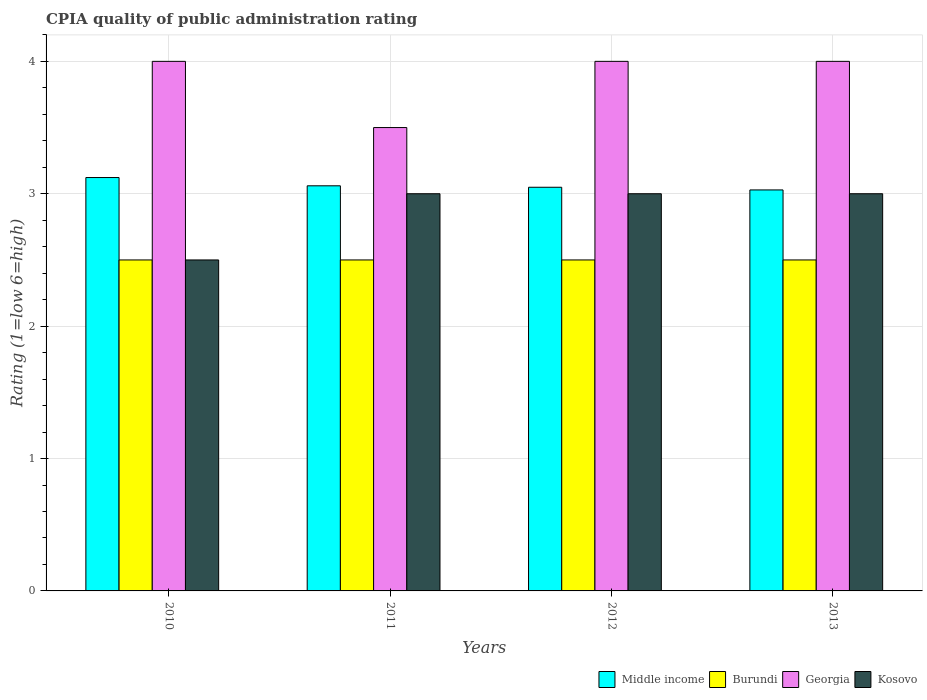What is the label of the 3rd group of bars from the left?
Your answer should be compact. 2012. What is the CPIA rating in Middle income in 2012?
Your answer should be very brief. 3.05. Across all years, what is the minimum CPIA rating in Middle income?
Make the answer very short. 3.03. In which year was the CPIA rating in Kosovo maximum?
Make the answer very short. 2011. What is the difference between the CPIA rating in Middle income in 2012 and the CPIA rating in Georgia in 2013?
Your answer should be compact. -0.95. What is the average CPIA rating in Georgia per year?
Ensure brevity in your answer.  3.88. In the year 2012, what is the difference between the CPIA rating in Middle income and CPIA rating in Kosovo?
Your response must be concise. 0.05. In how many years, is the CPIA rating in Middle income greater than 2?
Give a very brief answer. 4. What is the difference between the highest and the second highest CPIA rating in Kosovo?
Your answer should be compact. 0. Is it the case that in every year, the sum of the CPIA rating in Burundi and CPIA rating in Kosovo is greater than the sum of CPIA rating in Middle income and CPIA rating in Georgia?
Give a very brief answer. No. What does the 3rd bar from the left in 2010 represents?
Your answer should be compact. Georgia. Is it the case that in every year, the sum of the CPIA rating in Burundi and CPIA rating in Georgia is greater than the CPIA rating in Middle income?
Your answer should be compact. Yes. Are all the bars in the graph horizontal?
Offer a terse response. No. What is the difference between two consecutive major ticks on the Y-axis?
Make the answer very short. 1. Are the values on the major ticks of Y-axis written in scientific E-notation?
Provide a short and direct response. No. Does the graph contain grids?
Ensure brevity in your answer.  Yes. Where does the legend appear in the graph?
Give a very brief answer. Bottom right. What is the title of the graph?
Give a very brief answer. CPIA quality of public administration rating. What is the label or title of the X-axis?
Your response must be concise. Years. What is the Rating (1=low 6=high) of Middle income in 2010?
Offer a very short reply. 3.12. What is the Rating (1=low 6=high) in Kosovo in 2010?
Your answer should be compact. 2.5. What is the Rating (1=low 6=high) in Middle income in 2011?
Your response must be concise. 3.06. What is the Rating (1=low 6=high) in Burundi in 2011?
Your answer should be compact. 2.5. What is the Rating (1=low 6=high) in Georgia in 2011?
Keep it short and to the point. 3.5. What is the Rating (1=low 6=high) in Middle income in 2012?
Offer a terse response. 3.05. What is the Rating (1=low 6=high) of Kosovo in 2012?
Make the answer very short. 3. What is the Rating (1=low 6=high) of Middle income in 2013?
Make the answer very short. 3.03. What is the Rating (1=low 6=high) of Burundi in 2013?
Your response must be concise. 2.5. What is the Rating (1=low 6=high) of Georgia in 2013?
Provide a short and direct response. 4. What is the Rating (1=low 6=high) in Kosovo in 2013?
Provide a succinct answer. 3. Across all years, what is the maximum Rating (1=low 6=high) of Middle income?
Your answer should be compact. 3.12. Across all years, what is the maximum Rating (1=low 6=high) in Burundi?
Your response must be concise. 2.5. Across all years, what is the maximum Rating (1=low 6=high) of Georgia?
Offer a very short reply. 4. Across all years, what is the maximum Rating (1=low 6=high) of Kosovo?
Your response must be concise. 3. Across all years, what is the minimum Rating (1=low 6=high) in Middle income?
Offer a terse response. 3.03. Across all years, what is the minimum Rating (1=low 6=high) in Georgia?
Your answer should be very brief. 3.5. What is the total Rating (1=low 6=high) of Middle income in the graph?
Your answer should be very brief. 12.26. What is the total Rating (1=low 6=high) of Burundi in the graph?
Your answer should be compact. 10. What is the total Rating (1=low 6=high) in Kosovo in the graph?
Offer a terse response. 11.5. What is the difference between the Rating (1=low 6=high) in Middle income in 2010 and that in 2011?
Ensure brevity in your answer.  0.06. What is the difference between the Rating (1=low 6=high) of Georgia in 2010 and that in 2011?
Provide a short and direct response. 0.5. What is the difference between the Rating (1=low 6=high) in Middle income in 2010 and that in 2012?
Make the answer very short. 0.07. What is the difference between the Rating (1=low 6=high) in Burundi in 2010 and that in 2012?
Your answer should be compact. 0. What is the difference between the Rating (1=low 6=high) in Georgia in 2010 and that in 2012?
Keep it short and to the point. 0. What is the difference between the Rating (1=low 6=high) in Middle income in 2010 and that in 2013?
Provide a short and direct response. 0.09. What is the difference between the Rating (1=low 6=high) in Georgia in 2010 and that in 2013?
Keep it short and to the point. 0. What is the difference between the Rating (1=low 6=high) of Kosovo in 2010 and that in 2013?
Make the answer very short. -0.5. What is the difference between the Rating (1=low 6=high) in Middle income in 2011 and that in 2012?
Provide a short and direct response. 0.01. What is the difference between the Rating (1=low 6=high) of Georgia in 2011 and that in 2012?
Ensure brevity in your answer.  -0.5. What is the difference between the Rating (1=low 6=high) in Kosovo in 2011 and that in 2012?
Offer a terse response. 0. What is the difference between the Rating (1=low 6=high) in Middle income in 2011 and that in 2013?
Ensure brevity in your answer.  0.03. What is the difference between the Rating (1=low 6=high) in Georgia in 2011 and that in 2013?
Make the answer very short. -0.5. What is the difference between the Rating (1=low 6=high) of Middle income in 2012 and that in 2013?
Your answer should be very brief. 0.02. What is the difference between the Rating (1=low 6=high) in Georgia in 2012 and that in 2013?
Ensure brevity in your answer.  0. What is the difference between the Rating (1=low 6=high) in Kosovo in 2012 and that in 2013?
Offer a terse response. 0. What is the difference between the Rating (1=low 6=high) in Middle income in 2010 and the Rating (1=low 6=high) in Burundi in 2011?
Give a very brief answer. 0.62. What is the difference between the Rating (1=low 6=high) of Middle income in 2010 and the Rating (1=low 6=high) of Georgia in 2011?
Make the answer very short. -0.38. What is the difference between the Rating (1=low 6=high) in Middle income in 2010 and the Rating (1=low 6=high) in Kosovo in 2011?
Keep it short and to the point. 0.12. What is the difference between the Rating (1=low 6=high) of Middle income in 2010 and the Rating (1=low 6=high) of Burundi in 2012?
Ensure brevity in your answer.  0.62. What is the difference between the Rating (1=low 6=high) in Middle income in 2010 and the Rating (1=low 6=high) in Georgia in 2012?
Provide a short and direct response. -0.88. What is the difference between the Rating (1=low 6=high) in Middle income in 2010 and the Rating (1=low 6=high) in Kosovo in 2012?
Offer a terse response. 0.12. What is the difference between the Rating (1=low 6=high) of Burundi in 2010 and the Rating (1=low 6=high) of Georgia in 2012?
Keep it short and to the point. -1.5. What is the difference between the Rating (1=low 6=high) in Georgia in 2010 and the Rating (1=low 6=high) in Kosovo in 2012?
Ensure brevity in your answer.  1. What is the difference between the Rating (1=low 6=high) of Middle income in 2010 and the Rating (1=low 6=high) of Burundi in 2013?
Offer a very short reply. 0.62. What is the difference between the Rating (1=low 6=high) of Middle income in 2010 and the Rating (1=low 6=high) of Georgia in 2013?
Give a very brief answer. -0.88. What is the difference between the Rating (1=low 6=high) in Middle income in 2010 and the Rating (1=low 6=high) in Kosovo in 2013?
Provide a succinct answer. 0.12. What is the difference between the Rating (1=low 6=high) of Burundi in 2010 and the Rating (1=low 6=high) of Georgia in 2013?
Your answer should be compact. -1.5. What is the difference between the Rating (1=low 6=high) of Burundi in 2010 and the Rating (1=low 6=high) of Kosovo in 2013?
Make the answer very short. -0.5. What is the difference between the Rating (1=low 6=high) of Georgia in 2010 and the Rating (1=low 6=high) of Kosovo in 2013?
Offer a terse response. 1. What is the difference between the Rating (1=low 6=high) of Middle income in 2011 and the Rating (1=low 6=high) of Burundi in 2012?
Your answer should be compact. 0.56. What is the difference between the Rating (1=low 6=high) of Middle income in 2011 and the Rating (1=low 6=high) of Georgia in 2012?
Give a very brief answer. -0.94. What is the difference between the Rating (1=low 6=high) in Burundi in 2011 and the Rating (1=low 6=high) in Georgia in 2012?
Make the answer very short. -1.5. What is the difference between the Rating (1=low 6=high) in Burundi in 2011 and the Rating (1=low 6=high) in Kosovo in 2012?
Offer a terse response. -0.5. What is the difference between the Rating (1=low 6=high) in Middle income in 2011 and the Rating (1=low 6=high) in Burundi in 2013?
Offer a very short reply. 0.56. What is the difference between the Rating (1=low 6=high) of Middle income in 2011 and the Rating (1=low 6=high) of Georgia in 2013?
Your answer should be very brief. -0.94. What is the difference between the Rating (1=low 6=high) of Middle income in 2011 and the Rating (1=low 6=high) of Kosovo in 2013?
Provide a succinct answer. 0.06. What is the difference between the Rating (1=low 6=high) in Burundi in 2011 and the Rating (1=low 6=high) in Georgia in 2013?
Offer a terse response. -1.5. What is the difference between the Rating (1=low 6=high) in Middle income in 2012 and the Rating (1=low 6=high) in Burundi in 2013?
Ensure brevity in your answer.  0.55. What is the difference between the Rating (1=low 6=high) in Middle income in 2012 and the Rating (1=low 6=high) in Georgia in 2013?
Your answer should be compact. -0.95. What is the difference between the Rating (1=low 6=high) of Middle income in 2012 and the Rating (1=low 6=high) of Kosovo in 2013?
Keep it short and to the point. 0.05. What is the average Rating (1=low 6=high) in Middle income per year?
Provide a succinct answer. 3.07. What is the average Rating (1=low 6=high) of Georgia per year?
Provide a short and direct response. 3.88. What is the average Rating (1=low 6=high) of Kosovo per year?
Offer a terse response. 2.88. In the year 2010, what is the difference between the Rating (1=low 6=high) in Middle income and Rating (1=low 6=high) in Burundi?
Your response must be concise. 0.62. In the year 2010, what is the difference between the Rating (1=low 6=high) in Middle income and Rating (1=low 6=high) in Georgia?
Provide a succinct answer. -0.88. In the year 2010, what is the difference between the Rating (1=low 6=high) of Middle income and Rating (1=low 6=high) of Kosovo?
Provide a succinct answer. 0.62. In the year 2010, what is the difference between the Rating (1=low 6=high) of Georgia and Rating (1=low 6=high) of Kosovo?
Your response must be concise. 1.5. In the year 2011, what is the difference between the Rating (1=low 6=high) of Middle income and Rating (1=low 6=high) of Burundi?
Your answer should be very brief. 0.56. In the year 2011, what is the difference between the Rating (1=low 6=high) of Middle income and Rating (1=low 6=high) of Georgia?
Make the answer very short. -0.44. In the year 2011, what is the difference between the Rating (1=low 6=high) of Middle income and Rating (1=low 6=high) of Kosovo?
Provide a succinct answer. 0.06. In the year 2011, what is the difference between the Rating (1=low 6=high) of Burundi and Rating (1=low 6=high) of Georgia?
Provide a short and direct response. -1. In the year 2011, what is the difference between the Rating (1=low 6=high) in Burundi and Rating (1=low 6=high) in Kosovo?
Your response must be concise. -0.5. In the year 2011, what is the difference between the Rating (1=low 6=high) of Georgia and Rating (1=low 6=high) of Kosovo?
Offer a terse response. 0.5. In the year 2012, what is the difference between the Rating (1=low 6=high) of Middle income and Rating (1=low 6=high) of Burundi?
Give a very brief answer. 0.55. In the year 2012, what is the difference between the Rating (1=low 6=high) in Middle income and Rating (1=low 6=high) in Georgia?
Ensure brevity in your answer.  -0.95. In the year 2012, what is the difference between the Rating (1=low 6=high) in Middle income and Rating (1=low 6=high) in Kosovo?
Provide a succinct answer. 0.05. In the year 2012, what is the difference between the Rating (1=low 6=high) in Burundi and Rating (1=low 6=high) in Georgia?
Your answer should be very brief. -1.5. In the year 2012, what is the difference between the Rating (1=low 6=high) in Burundi and Rating (1=low 6=high) in Kosovo?
Offer a very short reply. -0.5. In the year 2012, what is the difference between the Rating (1=low 6=high) of Georgia and Rating (1=low 6=high) of Kosovo?
Ensure brevity in your answer.  1. In the year 2013, what is the difference between the Rating (1=low 6=high) of Middle income and Rating (1=low 6=high) of Burundi?
Your answer should be very brief. 0.53. In the year 2013, what is the difference between the Rating (1=low 6=high) in Middle income and Rating (1=low 6=high) in Georgia?
Ensure brevity in your answer.  -0.97. In the year 2013, what is the difference between the Rating (1=low 6=high) of Middle income and Rating (1=low 6=high) of Kosovo?
Your answer should be very brief. 0.03. What is the ratio of the Rating (1=low 6=high) in Middle income in 2010 to that in 2011?
Offer a terse response. 1.02. What is the ratio of the Rating (1=low 6=high) of Burundi in 2010 to that in 2011?
Provide a short and direct response. 1. What is the ratio of the Rating (1=low 6=high) of Middle income in 2010 to that in 2012?
Make the answer very short. 1.02. What is the ratio of the Rating (1=low 6=high) in Middle income in 2010 to that in 2013?
Make the answer very short. 1.03. What is the ratio of the Rating (1=low 6=high) in Kosovo in 2010 to that in 2013?
Give a very brief answer. 0.83. What is the ratio of the Rating (1=low 6=high) of Middle income in 2011 to that in 2012?
Provide a short and direct response. 1. What is the ratio of the Rating (1=low 6=high) of Middle income in 2011 to that in 2013?
Your answer should be very brief. 1.01. What is the ratio of the Rating (1=low 6=high) of Georgia in 2011 to that in 2013?
Make the answer very short. 0.88. What is the ratio of the Rating (1=low 6=high) in Georgia in 2012 to that in 2013?
Your response must be concise. 1. What is the ratio of the Rating (1=low 6=high) in Kosovo in 2012 to that in 2013?
Your answer should be compact. 1. What is the difference between the highest and the second highest Rating (1=low 6=high) in Middle income?
Give a very brief answer. 0.06. What is the difference between the highest and the second highest Rating (1=low 6=high) of Georgia?
Your answer should be compact. 0. What is the difference between the highest and the second highest Rating (1=low 6=high) of Kosovo?
Your answer should be compact. 0. What is the difference between the highest and the lowest Rating (1=low 6=high) of Middle income?
Keep it short and to the point. 0.09. What is the difference between the highest and the lowest Rating (1=low 6=high) of Burundi?
Provide a short and direct response. 0. 